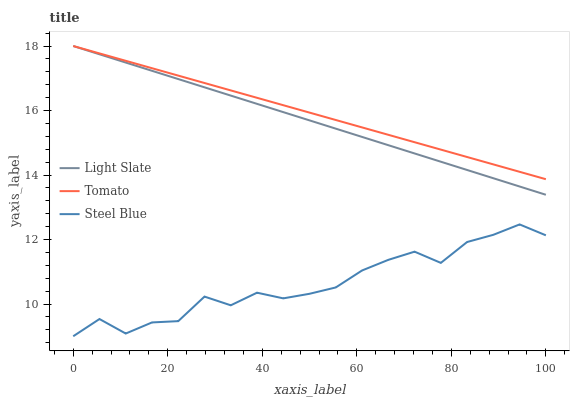Does Steel Blue have the minimum area under the curve?
Answer yes or no. Yes. Does Tomato have the maximum area under the curve?
Answer yes or no. Yes. Does Tomato have the minimum area under the curve?
Answer yes or no. No. Does Steel Blue have the maximum area under the curve?
Answer yes or no. No. Is Tomato the smoothest?
Answer yes or no. Yes. Is Steel Blue the roughest?
Answer yes or no. Yes. Is Steel Blue the smoothest?
Answer yes or no. No. Is Tomato the roughest?
Answer yes or no. No. Does Steel Blue have the lowest value?
Answer yes or no. Yes. Does Tomato have the lowest value?
Answer yes or no. No. Does Tomato have the highest value?
Answer yes or no. Yes. Does Steel Blue have the highest value?
Answer yes or no. No. Is Steel Blue less than Tomato?
Answer yes or no. Yes. Is Tomato greater than Steel Blue?
Answer yes or no. Yes. Does Light Slate intersect Tomato?
Answer yes or no. Yes. Is Light Slate less than Tomato?
Answer yes or no. No. Is Light Slate greater than Tomato?
Answer yes or no. No. Does Steel Blue intersect Tomato?
Answer yes or no. No. 